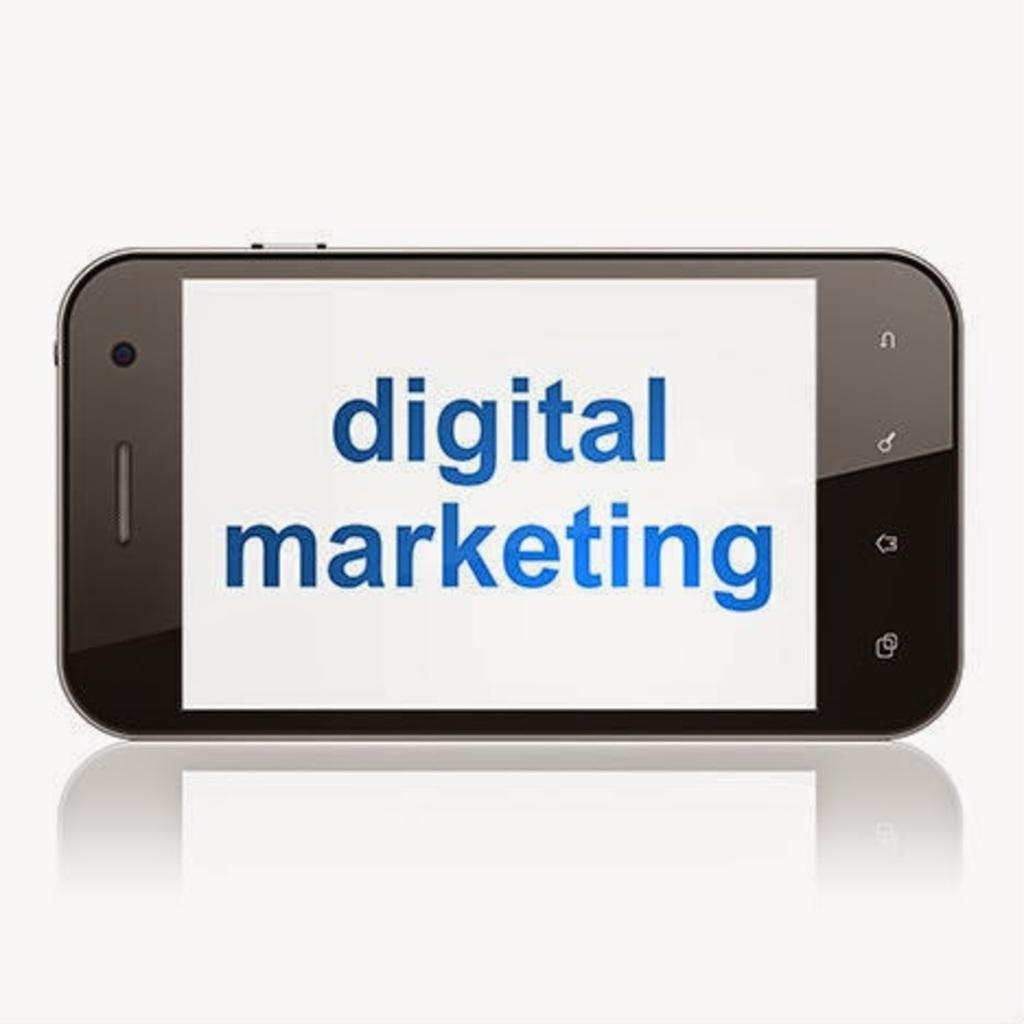<image>
Share a concise interpretation of the image provided. A cell phone sitting horizontally and displaying "digital marketing" on the screen. 